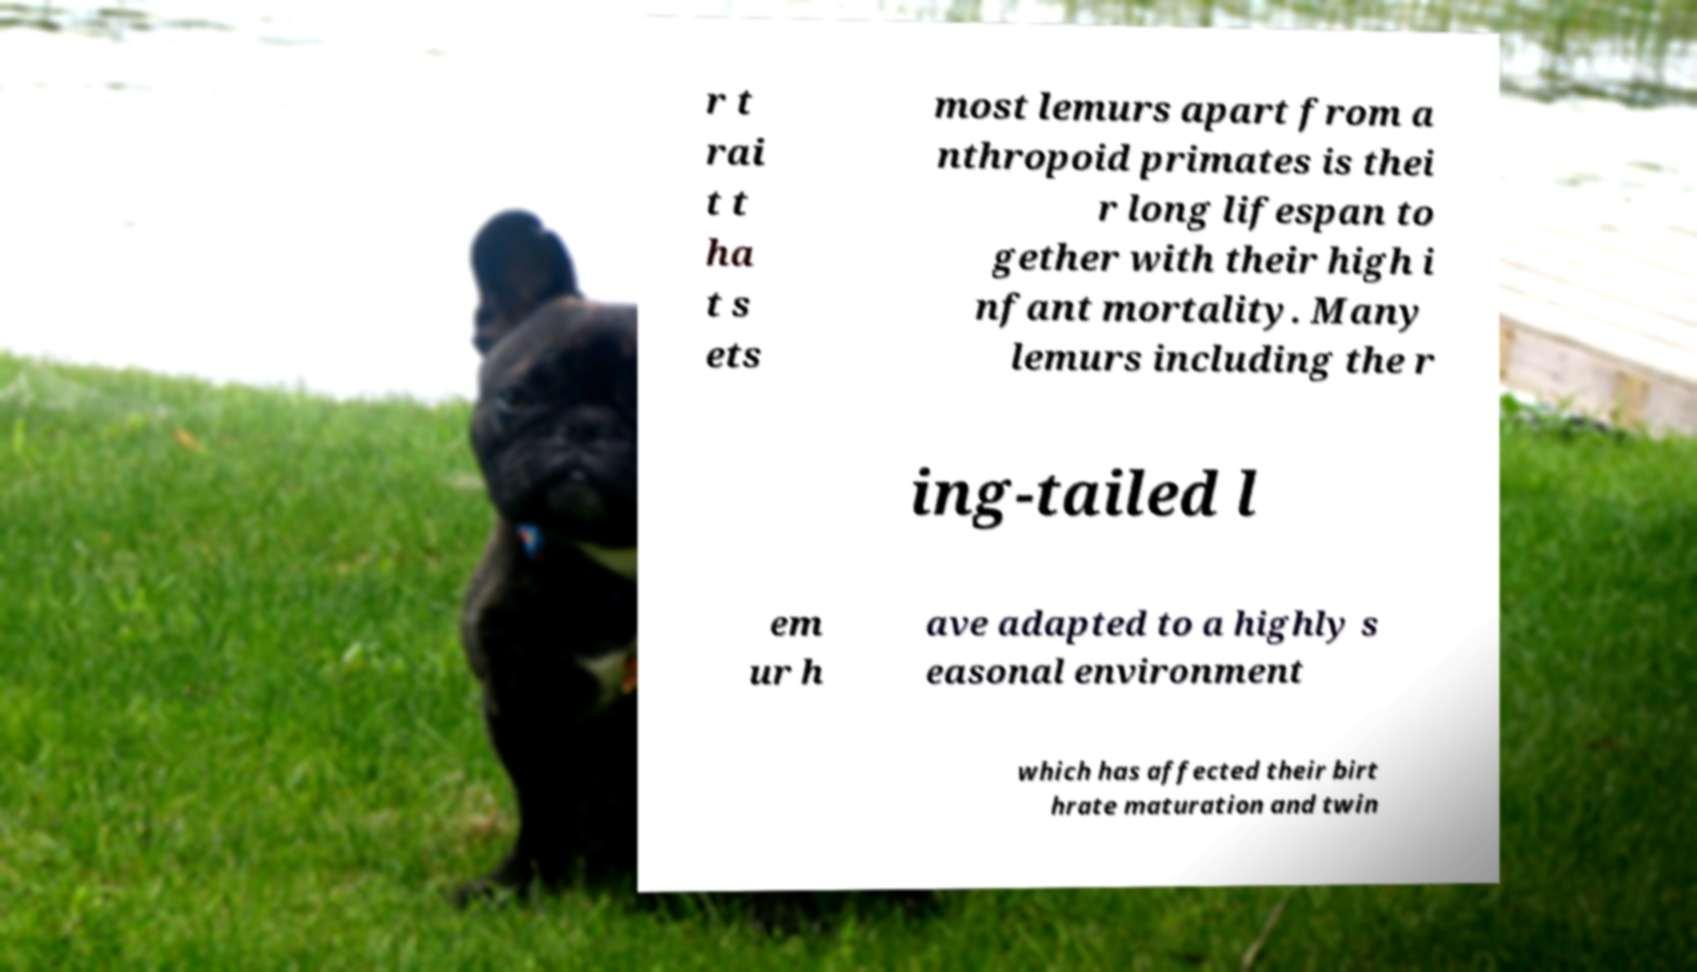Can you read and provide the text displayed in the image?This photo seems to have some interesting text. Can you extract and type it out for me? r t rai t t ha t s ets most lemurs apart from a nthropoid primates is thei r long lifespan to gether with their high i nfant mortality. Many lemurs including the r ing-tailed l em ur h ave adapted to a highly s easonal environment which has affected their birt hrate maturation and twin 